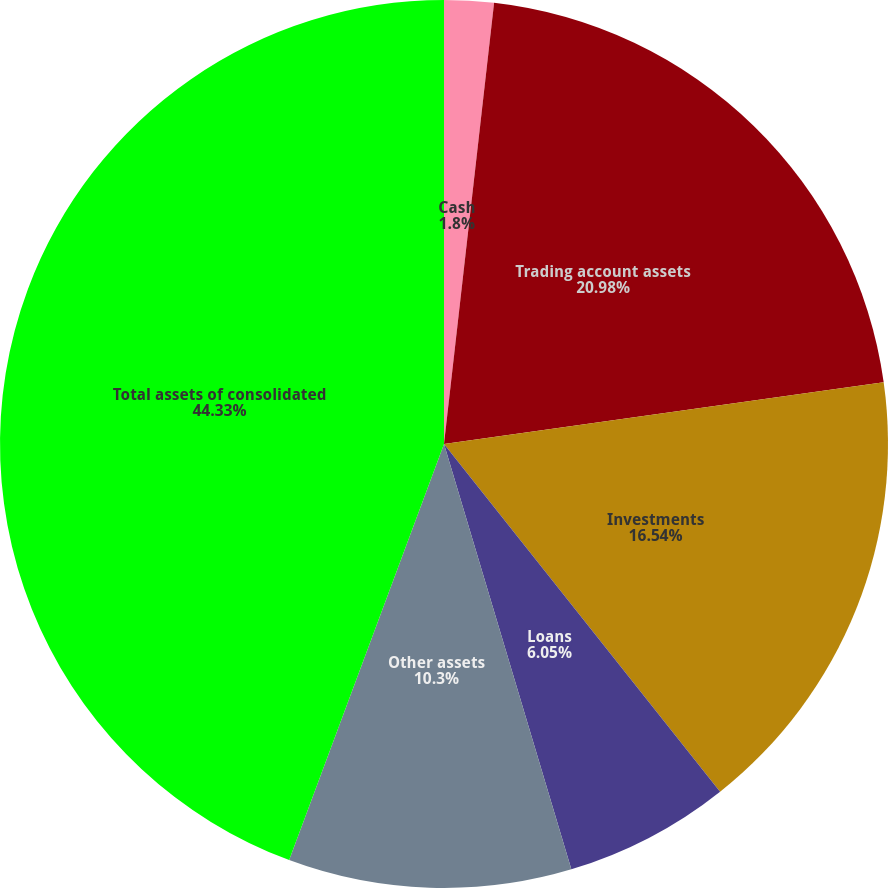<chart> <loc_0><loc_0><loc_500><loc_500><pie_chart><fcel>Cash<fcel>Trading account assets<fcel>Investments<fcel>Loans<fcel>Other assets<fcel>Total assets of consolidated<nl><fcel>1.8%<fcel>20.98%<fcel>16.54%<fcel>6.05%<fcel>10.3%<fcel>44.33%<nl></chart> 